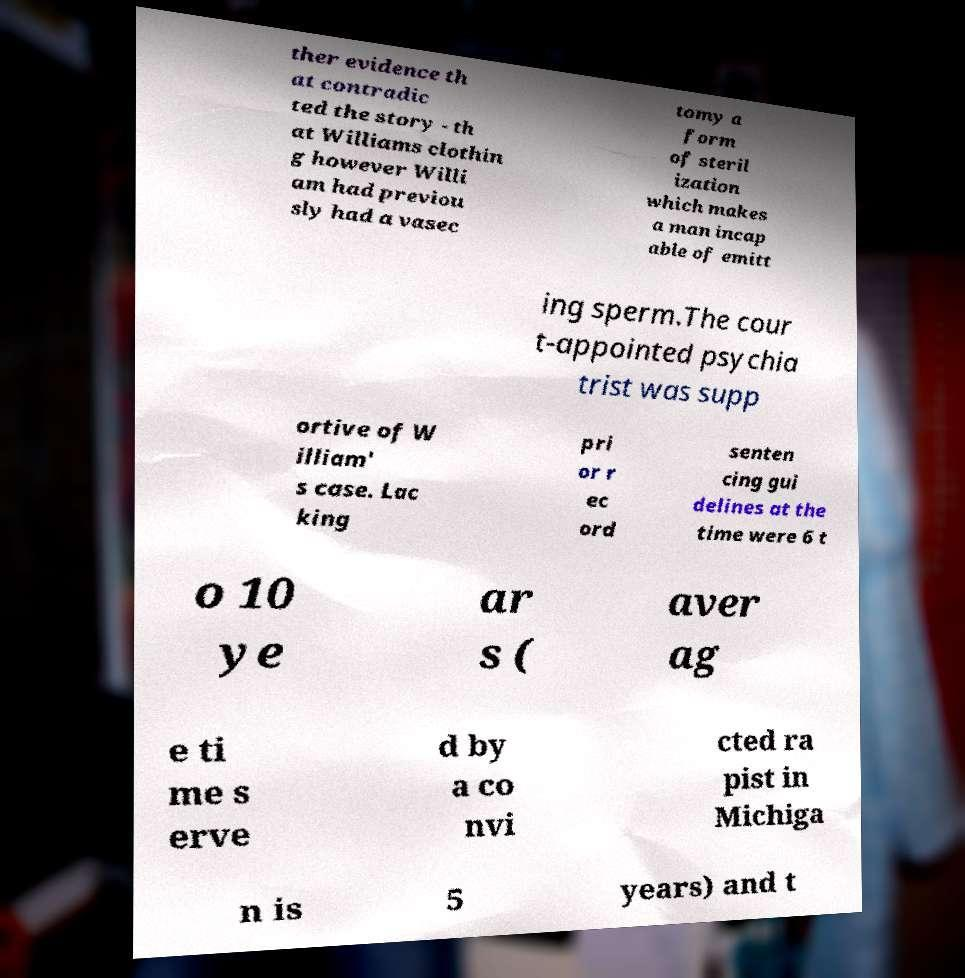Could you extract and type out the text from this image? ther evidence th at contradic ted the story - th at Williams clothin g however Willi am had previou sly had a vasec tomy a form of steril ization which makes a man incap able of emitt ing sperm.The cour t-appointed psychia trist was supp ortive of W illiam' s case. Lac king pri or r ec ord senten cing gui delines at the time were 6 t o 10 ye ar s ( aver ag e ti me s erve d by a co nvi cted ra pist in Michiga n is 5 years) and t 